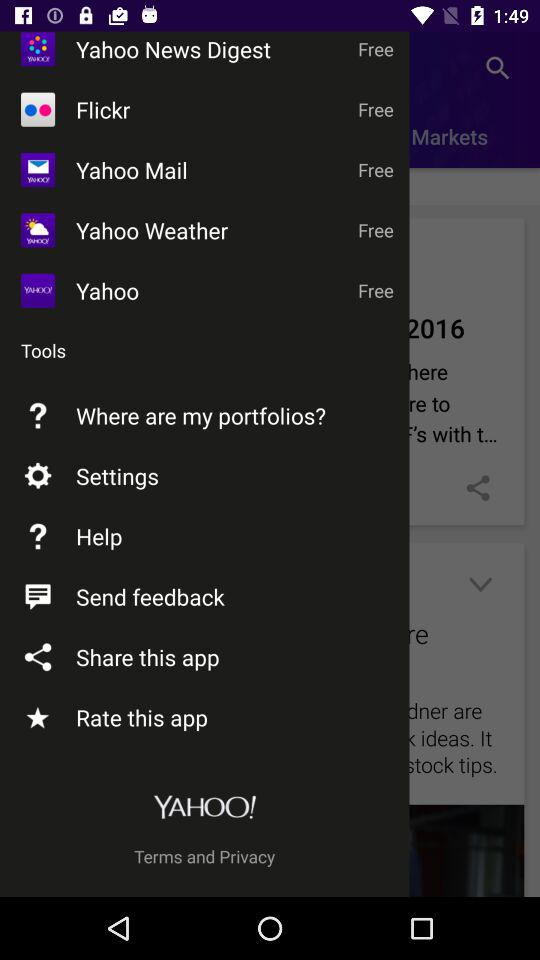What is the name of the application? The names of the applications are "Yahoo News Digest", "Flickr", "Yahoo Mail", "Yahoo Weather" and "Yahoo". 